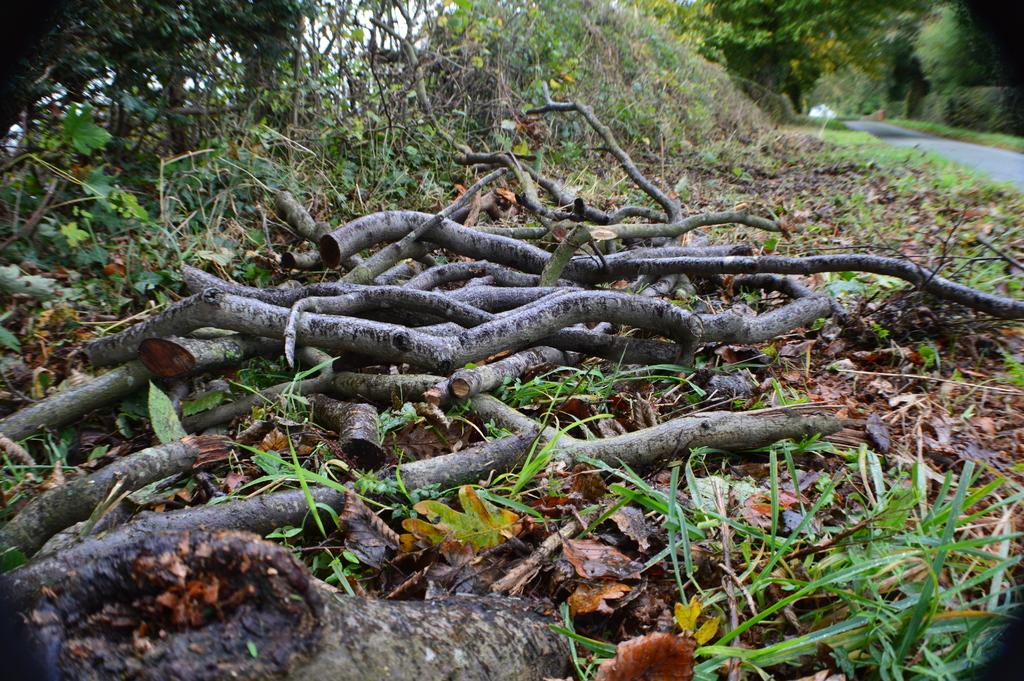What type of natural elements can be seen in the image? There are dry branches and leaves in the image. What type of vegetation is visible in the image? There are trees visible in the image. What type of man-made structure can be seen in the image? There is a road in the image. What type of berry is growing on the trees in the image? There is no mention of berries or any type of fruit growing on the trees in the image. 